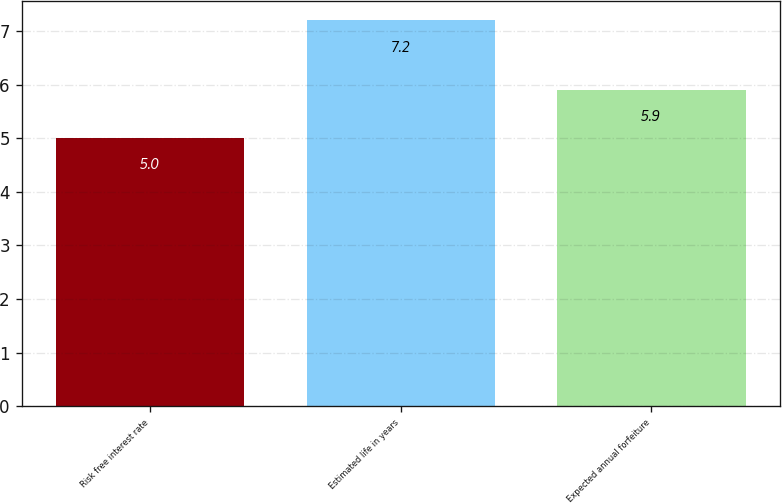Convert chart to OTSL. <chart><loc_0><loc_0><loc_500><loc_500><bar_chart><fcel>Risk free interest rate<fcel>Estimated life in years<fcel>Expected annual forfeiture<nl><fcel>5<fcel>7.2<fcel>5.9<nl></chart> 